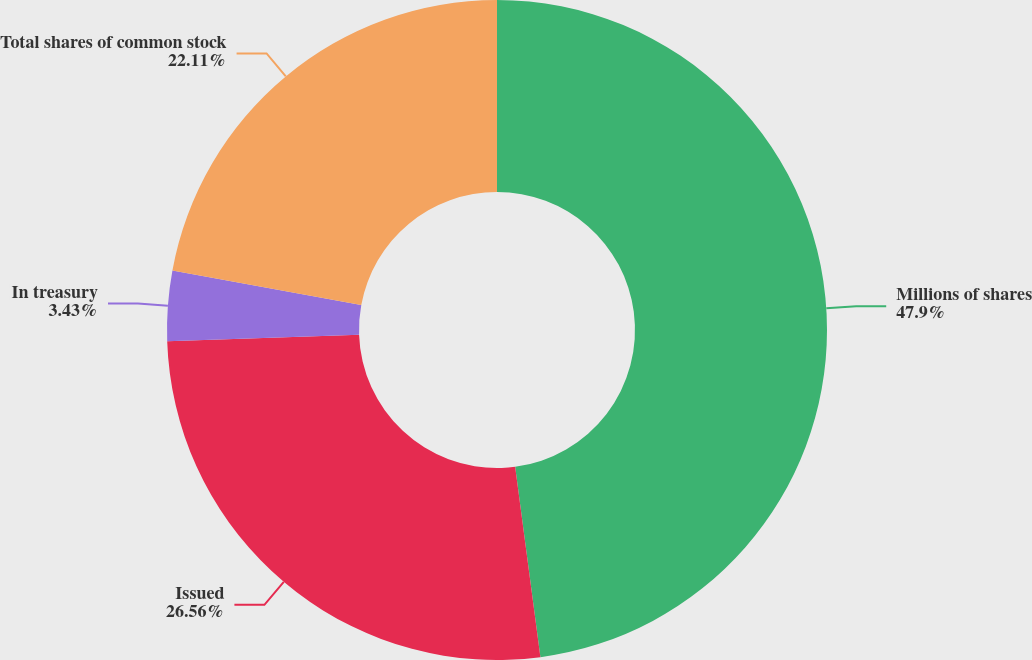Convert chart. <chart><loc_0><loc_0><loc_500><loc_500><pie_chart><fcel>Millions of shares<fcel>Issued<fcel>In treasury<fcel>Total shares of common stock<nl><fcel>47.9%<fcel>26.56%<fcel>3.43%<fcel>22.11%<nl></chart> 